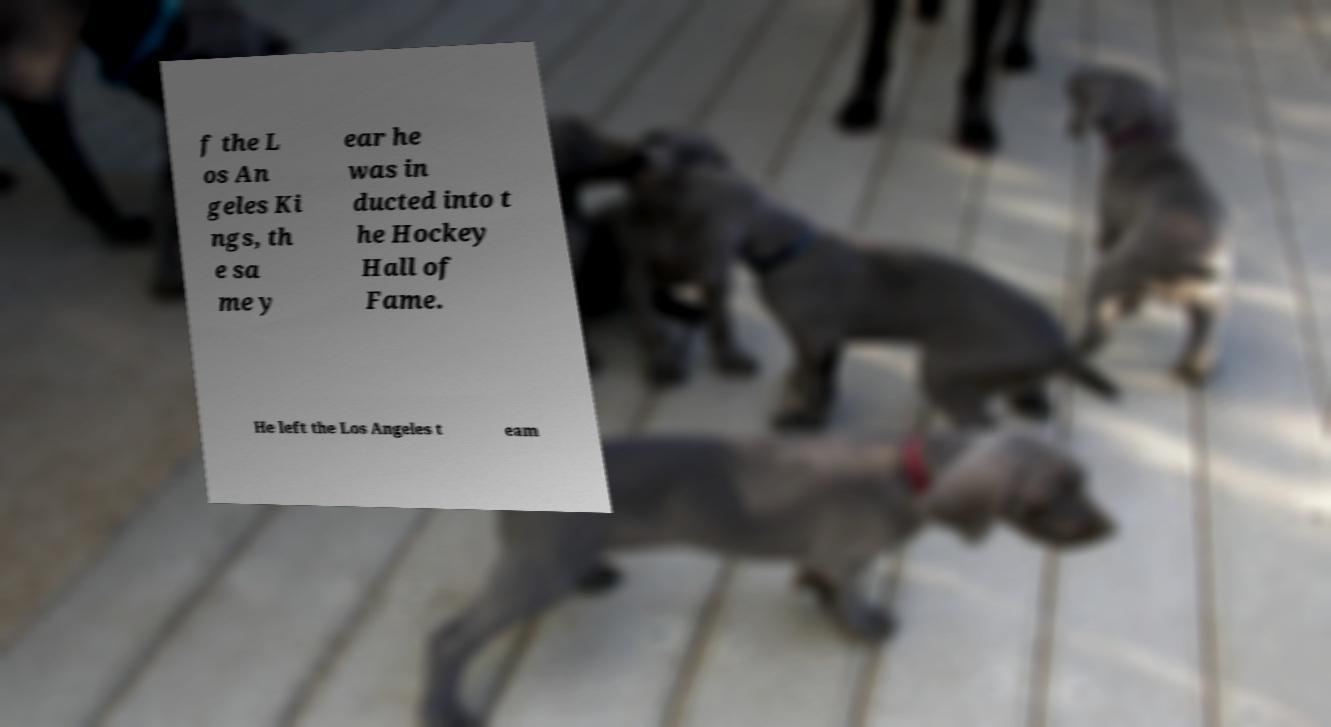There's text embedded in this image that I need extracted. Can you transcribe it verbatim? f the L os An geles Ki ngs, th e sa me y ear he was in ducted into t he Hockey Hall of Fame. He left the Los Angeles t eam 